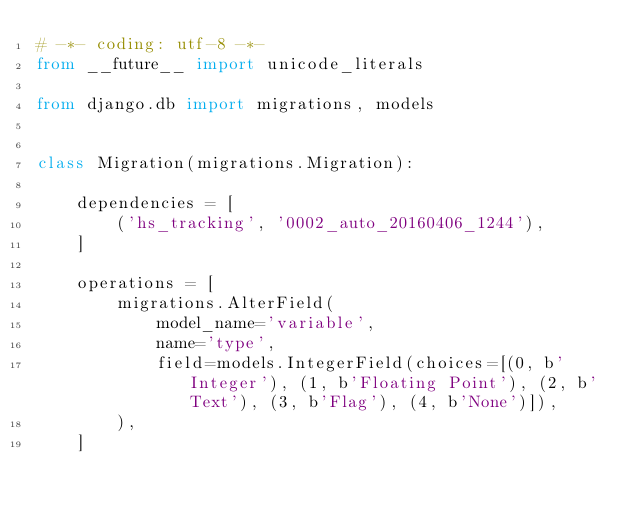Convert code to text. <code><loc_0><loc_0><loc_500><loc_500><_Python_># -*- coding: utf-8 -*-
from __future__ import unicode_literals

from django.db import migrations, models


class Migration(migrations.Migration):

    dependencies = [
        ('hs_tracking', '0002_auto_20160406_1244'),
    ]

    operations = [
        migrations.AlterField(
            model_name='variable',
            name='type',
            field=models.IntegerField(choices=[(0, b'Integer'), (1, b'Floating Point'), (2, b'Text'), (3, b'Flag'), (4, b'None')]),
        ),
    ]
</code> 